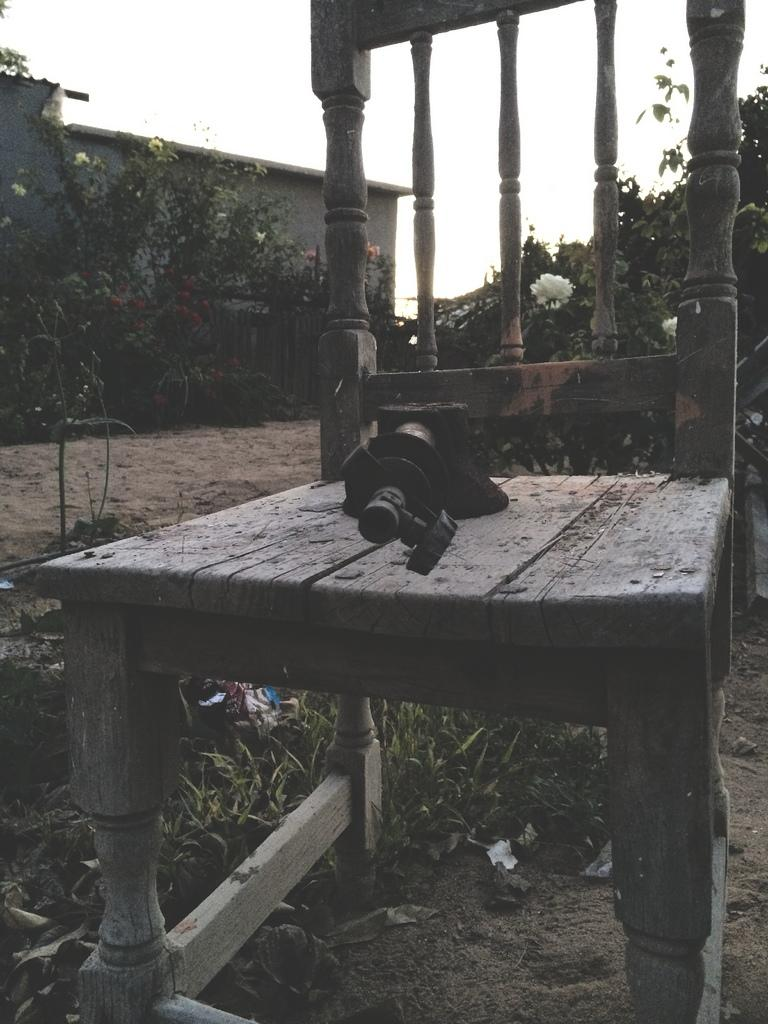What piece of furniture is present in the image? There is a chair in the image. What is placed on the chair? A camera is placed on the chair. What celestial bodies can be seen in the middle of the image? Planets are visible in the middle of the image. What part of the natural environment is visible on the left side of the image? The sky is visible on the left side of the image. What type of weather can be seen in the image? There is no weather visible in the image; it only shows a chair, a camera, planets, and the sky. What is the ground like in the image? There is no ground visible in the image; it only shows a chair, a camera, planets, and the sky. 